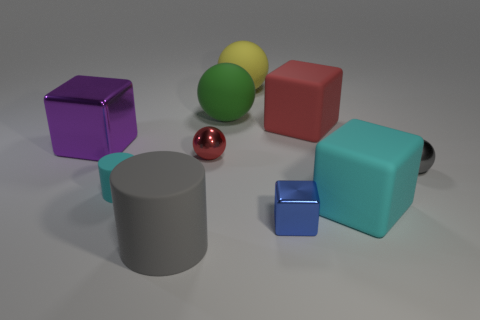Are there any other things that have the same color as the big cylinder?
Your response must be concise. Yes. The big matte object that is the same color as the small cylinder is what shape?
Keep it short and to the point. Cube. What is the size of the rubber cube behind the red shiny object?
Ensure brevity in your answer.  Large. The cyan object that is the same size as the gray metallic ball is what shape?
Ensure brevity in your answer.  Cylinder. Are the cyan object that is right of the large red object and the gray sphere that is on the right side of the blue block made of the same material?
Your response must be concise. No. What material is the large cube that is behind the block to the left of the large green object?
Provide a short and direct response. Rubber. How big is the metallic object in front of the sphere that is right of the matte sphere behind the green rubber sphere?
Your response must be concise. Small. Is the blue cube the same size as the yellow matte thing?
Ensure brevity in your answer.  No. Do the big thing to the left of the small rubber thing and the cyan thing on the right side of the small red shiny ball have the same shape?
Ensure brevity in your answer.  Yes. Is there a large cyan rubber cube that is right of the cyan thing on the right side of the tiny cube?
Your response must be concise. No. 